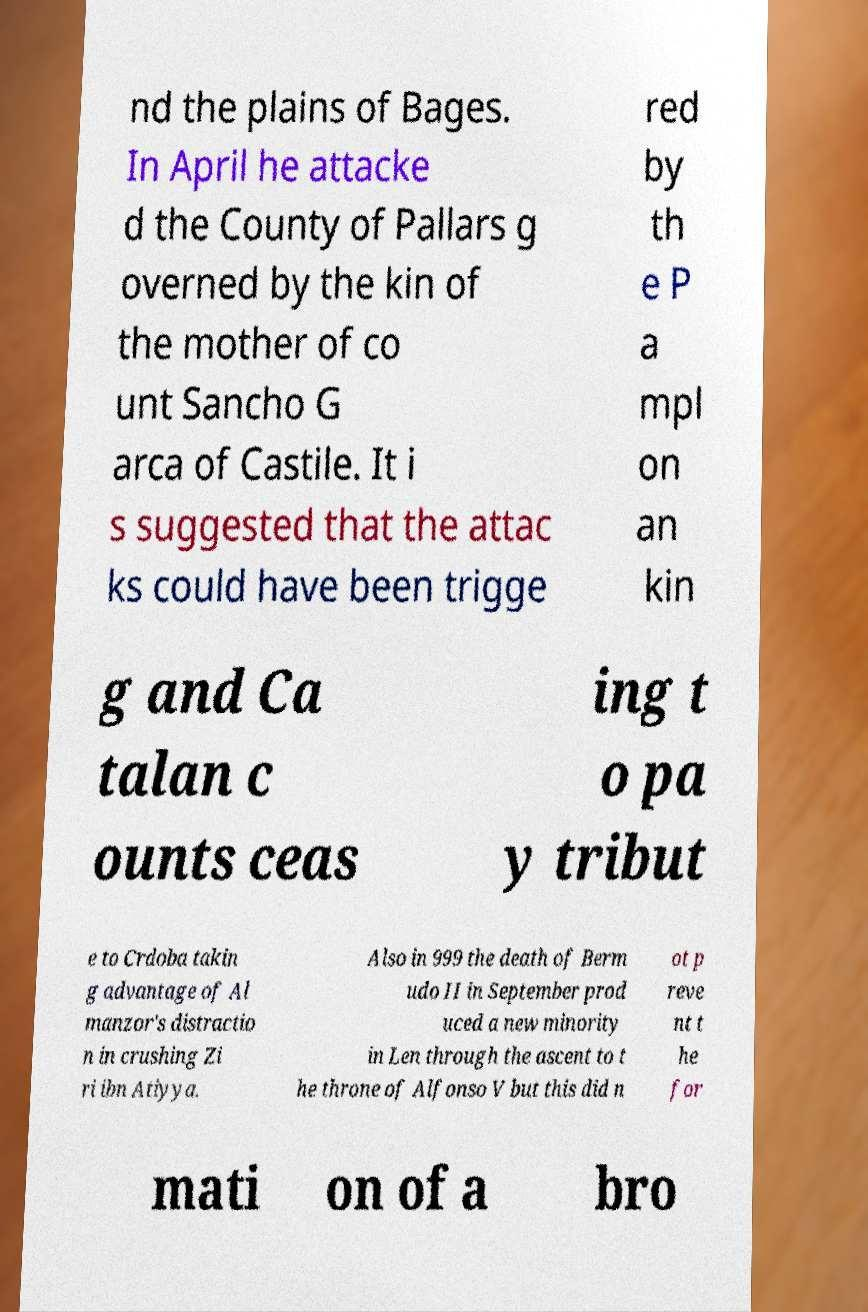Please identify and transcribe the text found in this image. nd the plains of Bages. In April he attacke d the County of Pallars g overned by the kin of the mother of co unt Sancho G arca of Castile. It i s suggested that the attac ks could have been trigge red by th e P a mpl on an kin g and Ca talan c ounts ceas ing t o pa y tribut e to Crdoba takin g advantage of Al manzor's distractio n in crushing Zi ri ibn Atiyya. Also in 999 the death of Berm udo II in September prod uced a new minority in Len through the ascent to t he throne of Alfonso V but this did n ot p reve nt t he for mati on of a bro 